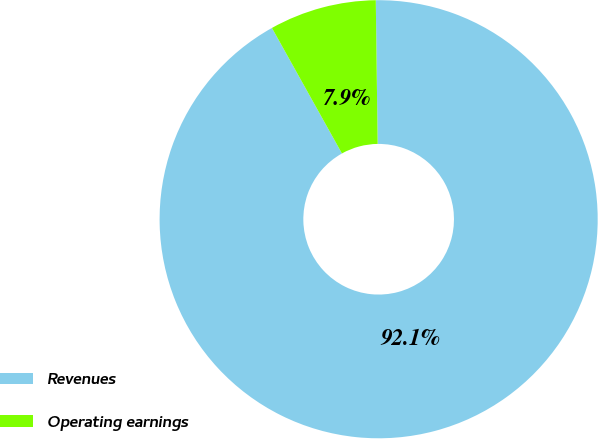Convert chart to OTSL. <chart><loc_0><loc_0><loc_500><loc_500><pie_chart><fcel>Revenues<fcel>Operating earnings<nl><fcel>92.11%<fcel>7.89%<nl></chart> 